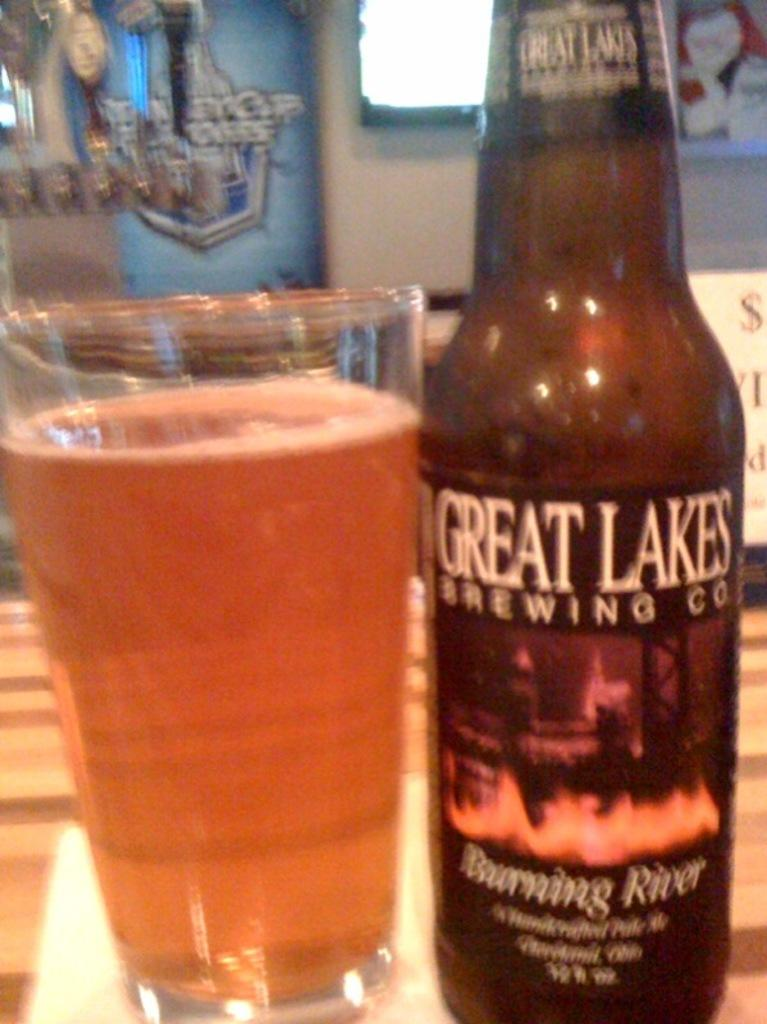<image>
Create a compact narrative representing the image presented. A bottle Burning River beer next to a glass full of beer. 